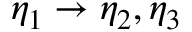<formula> <loc_0><loc_0><loc_500><loc_500>\eta _ { 1 } \rightarrow \eta _ { 2 } , \eta _ { 3 }</formula> 